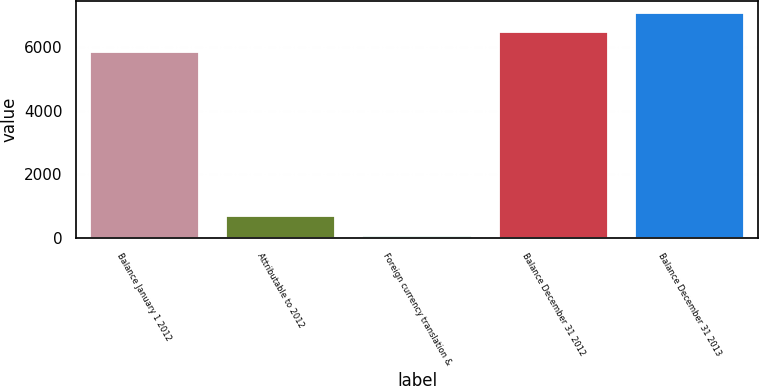Convert chart. <chart><loc_0><loc_0><loc_500><loc_500><bar_chart><fcel>Balance January 1 2012<fcel>Attributable to 2012<fcel>Foreign currency translation &<fcel>Balance December 31 2012<fcel>Balance December 31 2013<nl><fcel>5842<fcel>683.85<fcel>59.3<fcel>6466.55<fcel>7091.1<nl></chart> 